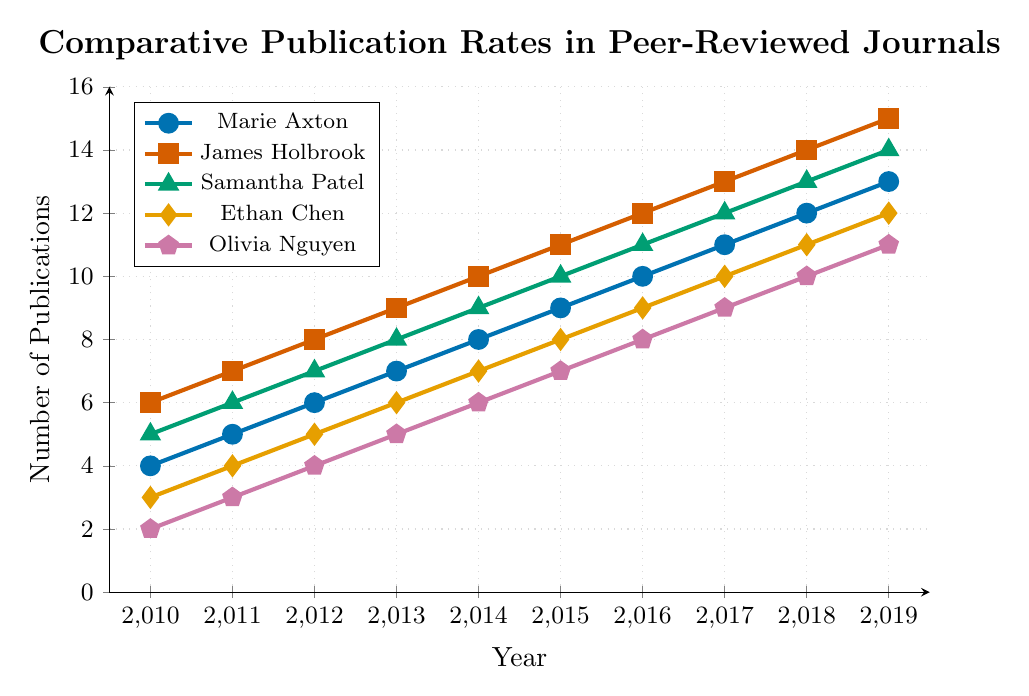Which year did Marie Axton's publication rate reach double digits? Observe Marie Axton's line (blue with circles) and note the year when it first reaches or exceeds 10 publications. The first point in double digits is at 2016 with a value of 10.
Answer: 2016 How many more publications did Samantha Patel have compared to Ethan Chen in 2015? Check Samantha Patel's line (green with triangles) and Ethan Chen's line (orange with diamonds) at the year 2015. Samantha had 10 publications and Ethan had 8. The difference is 10 - 8.
Answer: 2 What was the combined publication rate of Marie Axton and Olivia Nguyen in 2012? Look at Marie Axton's line (blue with circles) and Olivia Nguyen's line (purple with pentagons) for the year 2012. Marie published 6 times, and Olivia published 4 times. The combined rate is 6 + 4.
Answer: 10 Between 2014 and 2015, who had the highest increase in publication rates? Calculate the difference in publication rates between 2014 and 2015 for each person by subtracting the 2014 rates from the 2015 rates. Marie Axton: 9-8=1; James Holbrook: 11-10=1; Samantha Patel: 10-9=1; Ethan Chen: 8-7=1; Olivia Nguyen: 7-6=1. They all had the same increase of 1 publication.
Answer: All Whose publication rate was the closest to the average rate of all the colleagues in 2019? Calculate the average number of publications for all the colleagues in 2019: (13 + 15 + 14 + 12 + 11)/5 = 13. Evaluate who was closest to this average by comparing: Marie Axton: 13, James Holbrook: 15, Samantha Patel: 14, Ethan Chen: 12, Olivia Nguyen: 11. Marie Axton was exactly on the average.
Answer: Marie Axton Which colleague had a consistently higher publication rate than Marie Axton from 2010 to 2019? For each year from 2010 to 2019, compare Marie Axton's (blue with circles) publication rates with other colleagues. James Holbrook's (red with squares) publication rates were consistently higher every year.
Answer: James Holbrook By how much did Olivia Nguyen's publication rate increase from 2010 to 2019? Look at Olivia Nguyen's line (purple with pentagons) and note the publication rates for 2010 and 2019. 2010 had 2 publications, and 2019 had 11 publications. Increase is 11 - 2.
Answer: 9 Which two colleagues had the same publication rate in both 2014 and 2019? Check the publication rates for 2014 and 2019 for all colleagues. In 2014, Samantha Patel had 9 and so did Ethan Chen, and in 2019, Samantha Patel had 14 while Ethan Chen had 12, so it does not match. No two colleagues had the same value both years.
Answer: None In which year did Marie Axton's publication rate equal Ethan Chen's from the previous year? Compare each year's publication rate of Marie Axton (blue with circles) with Ethan Chen's (orange with diamonds) rate from the previous year. In 2014, Marie Axton had 8 publications, which matches Ethan Chen's 8 publications in 2013.
Answer: 2014 